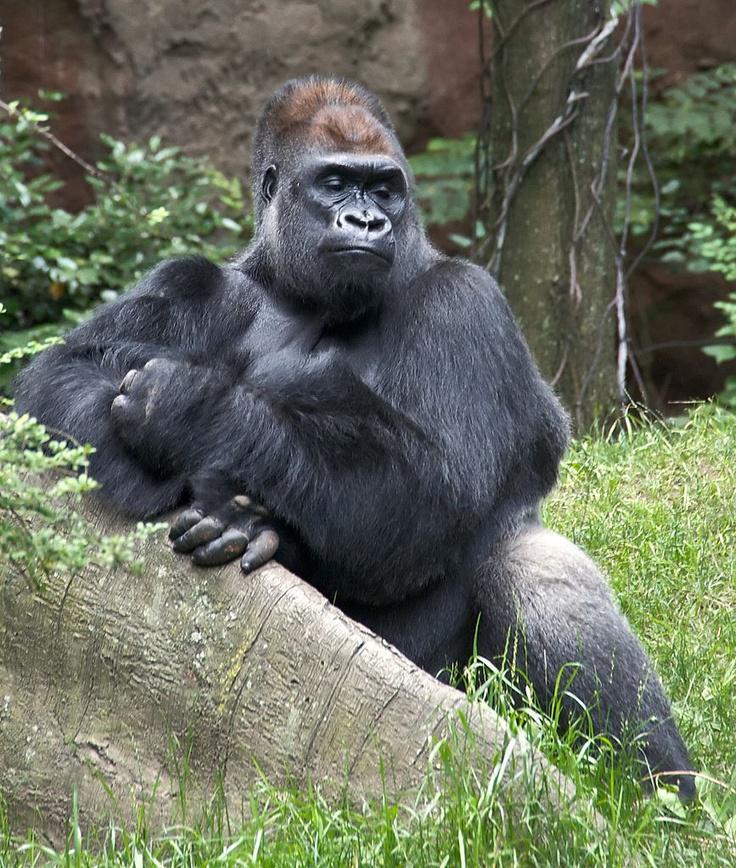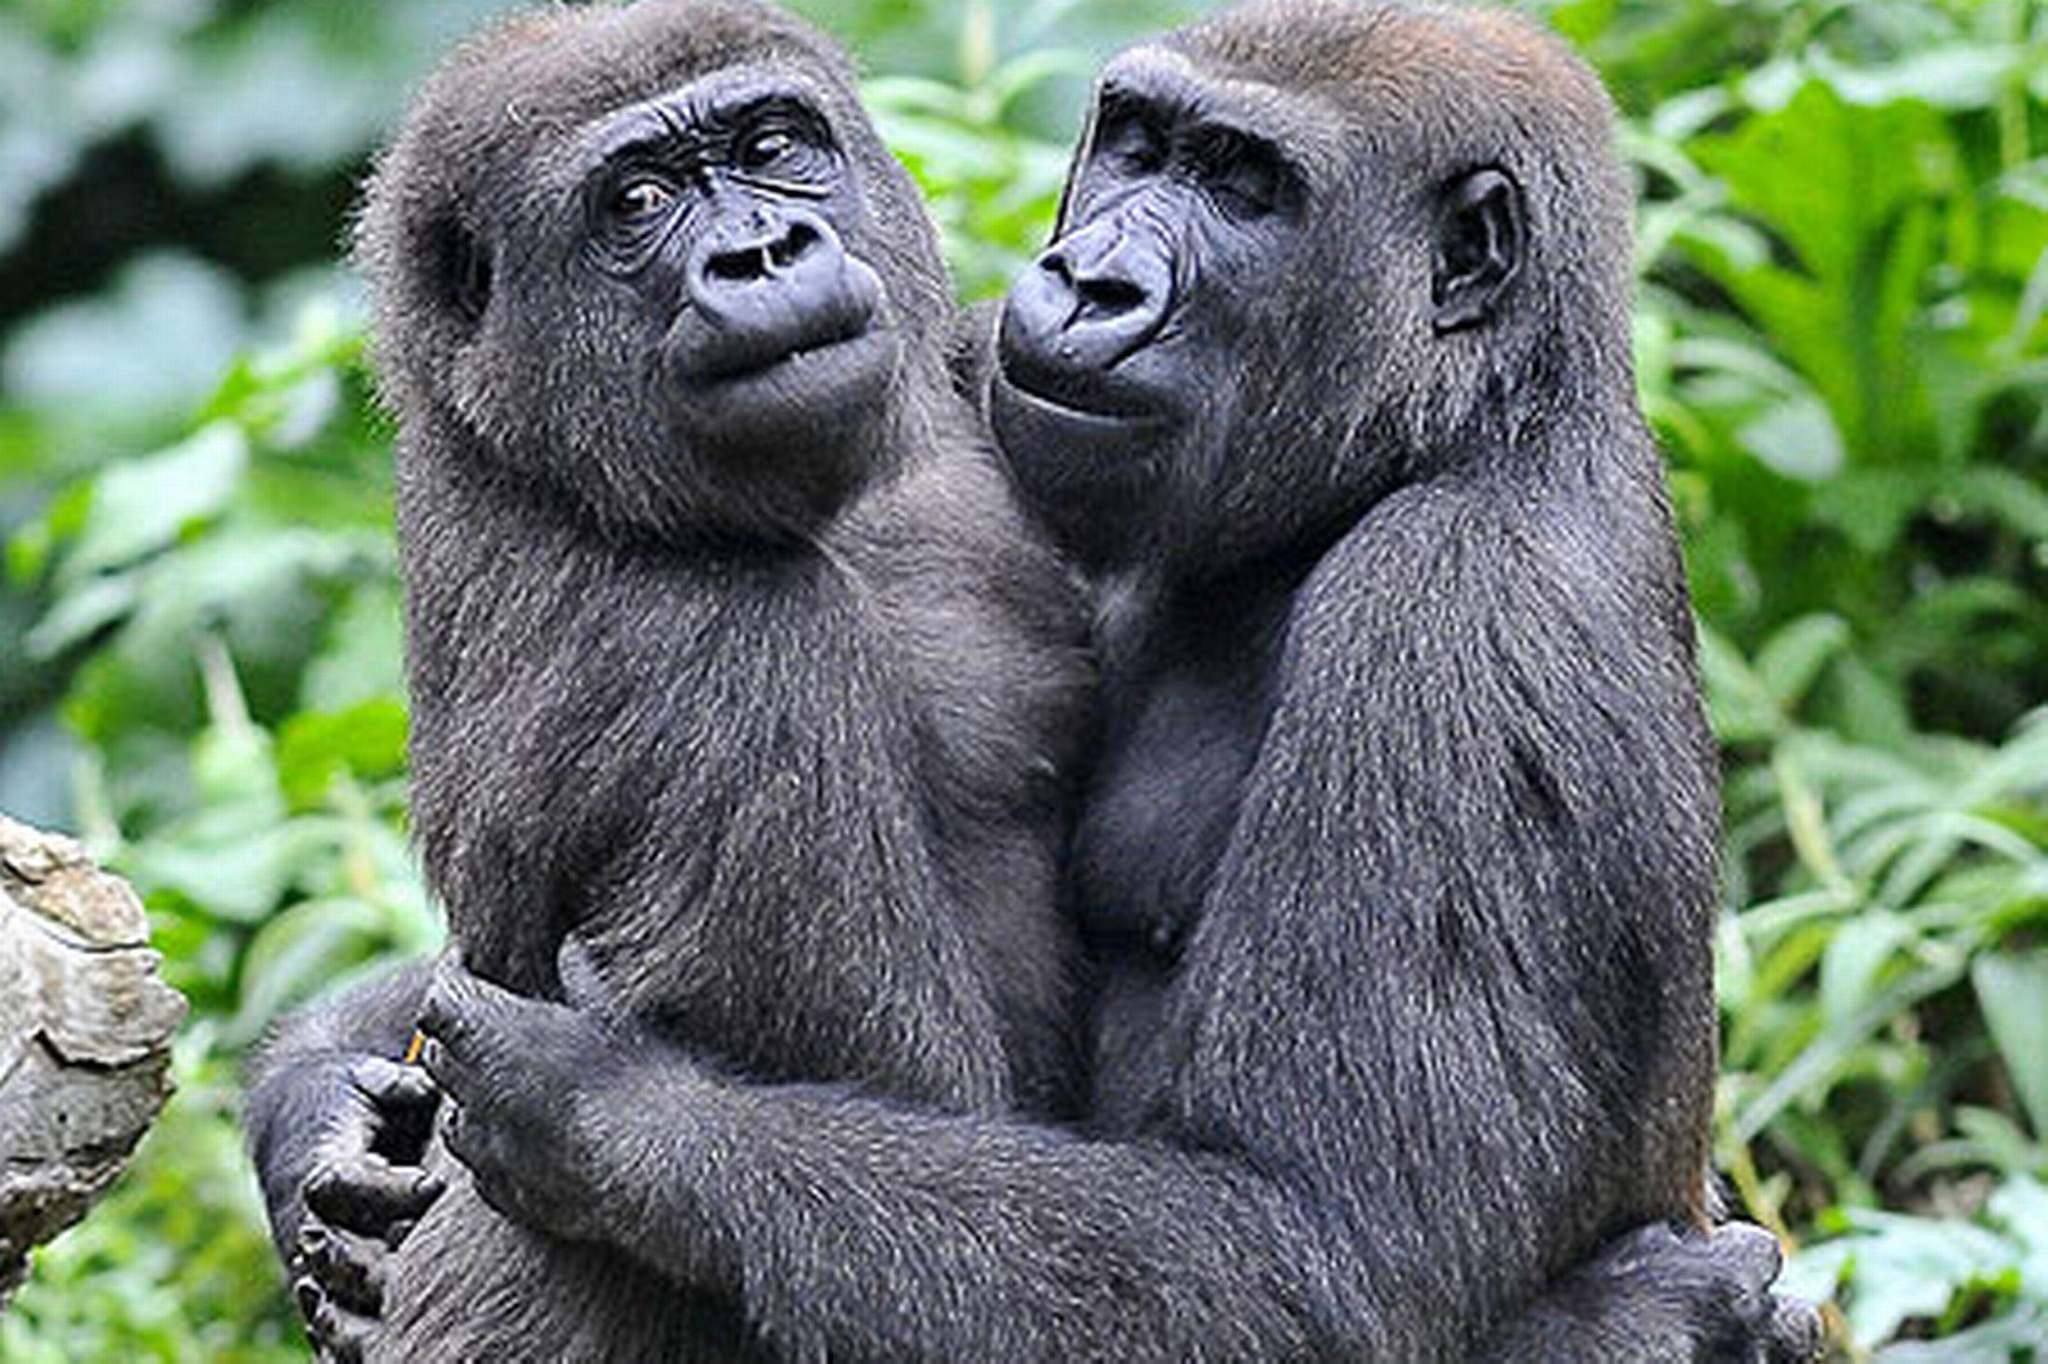The first image is the image on the left, the second image is the image on the right. Examine the images to the left and right. Is the description "There is a silverback gorilla sitting while crossing his arm over the other" accurate? Answer yes or no. Yes. The first image is the image on the left, the second image is the image on the right. Analyze the images presented: Is the assertion "the left and right image contains the same number of gorillas." valid? Answer yes or no. No. 